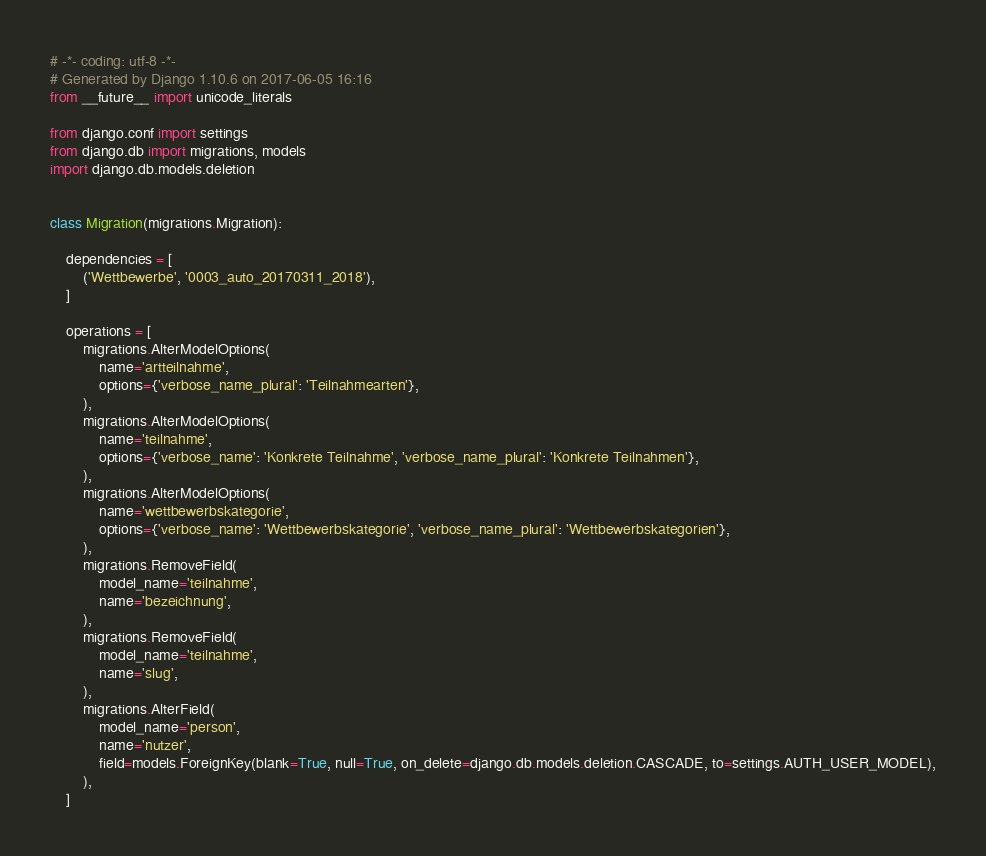<code> <loc_0><loc_0><loc_500><loc_500><_Python_># -*- coding: utf-8 -*-
# Generated by Django 1.10.6 on 2017-06-05 16:16
from __future__ import unicode_literals

from django.conf import settings
from django.db import migrations, models
import django.db.models.deletion


class Migration(migrations.Migration):

    dependencies = [
        ('Wettbewerbe', '0003_auto_20170311_2018'),
    ]

    operations = [
        migrations.AlterModelOptions(
            name='artteilnahme',
            options={'verbose_name_plural': 'Teilnahmearten'},
        ),
        migrations.AlterModelOptions(
            name='teilnahme',
            options={'verbose_name': 'Konkrete Teilnahme', 'verbose_name_plural': 'Konkrete Teilnahmen'},
        ),
        migrations.AlterModelOptions(
            name='wettbewerbskategorie',
            options={'verbose_name': 'Wettbewerbskategorie', 'verbose_name_plural': 'Wettbewerbskategorien'},
        ),
        migrations.RemoveField(
            model_name='teilnahme',
            name='bezeichnung',
        ),
        migrations.RemoveField(
            model_name='teilnahme',
            name='slug',
        ),
        migrations.AlterField(
            model_name='person',
            name='nutzer',
            field=models.ForeignKey(blank=True, null=True, on_delete=django.db.models.deletion.CASCADE, to=settings.AUTH_USER_MODEL),
        ),
    ]
</code> 